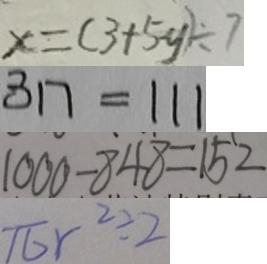Convert formula to latex. <formula><loc_0><loc_0><loc_500><loc_500>x = ( 3 + 5 y ) \div 7 
 3 1 7 = 1 1 1 
 1 0 0 0 - 8 4 8 = 1 5 2 
 \pi r ^ { 2 } \div 2</formula> 